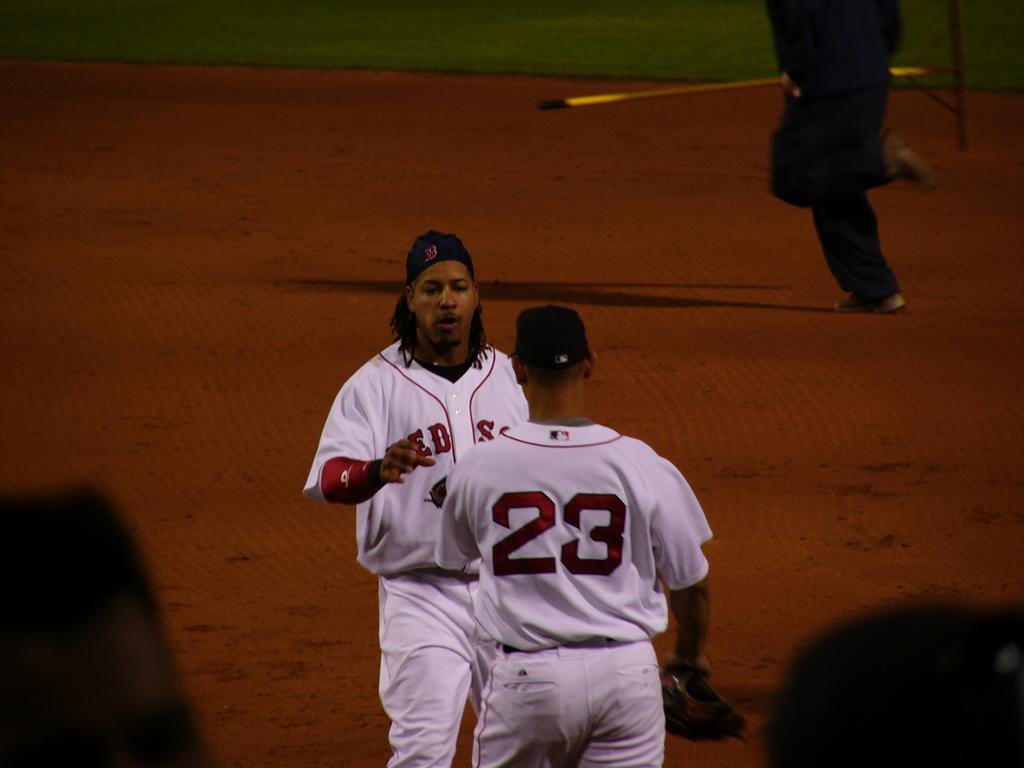What shirt number is the player with his back facing us wearing?
Offer a very short reply. 23. What team is this?
Give a very brief answer. Red sox. 